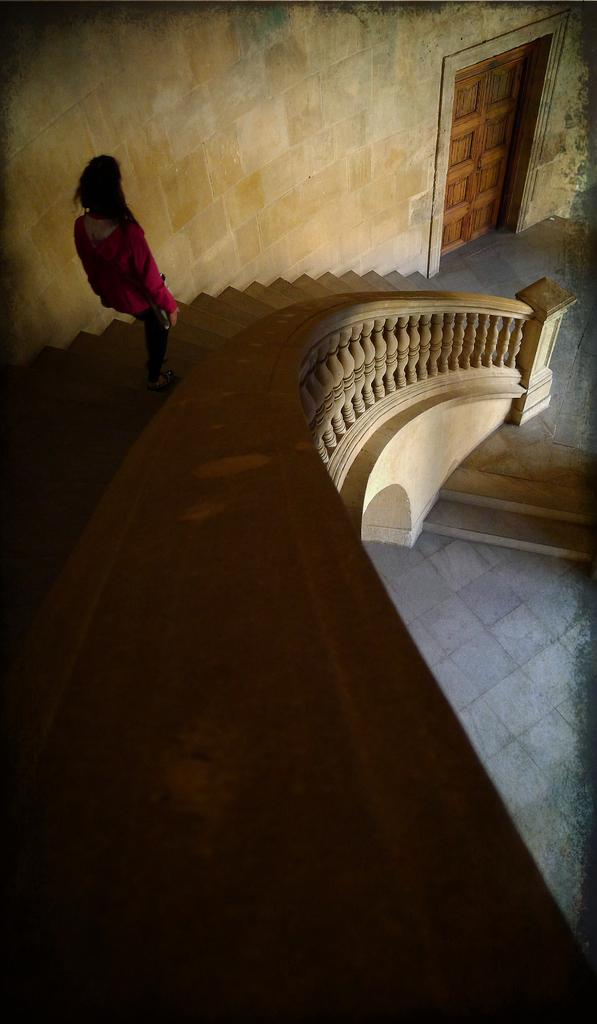What type of location is depicted in the image? The image shows an inside view of a building. Can you describe any people present in the image? There is a woman in the image. What architectural feature can be seen in the image? There are stairs visible in the image. What type of jewel is the woman wearing in the image? There is no mention of a jewel in the image, and the woman is not wearing any visible jewelry. Can you see any fairies in the image? There are no fairies present in the image; it only shows a woman and an interior view of a building. 